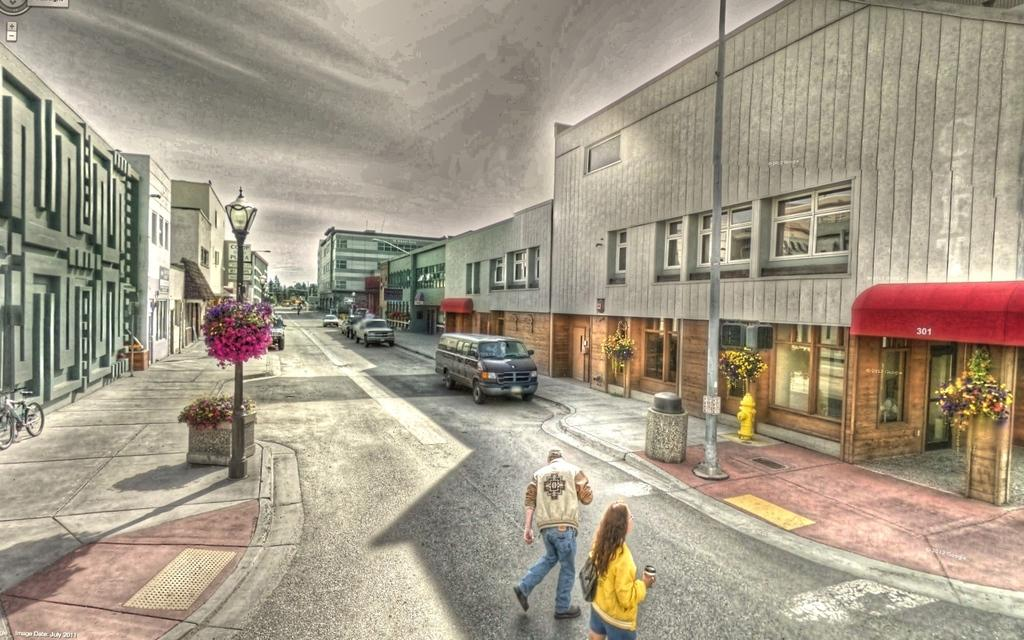What type of image is being described? The image is animated. What structures can be seen in the image? There are buildings in the image. What vehicles are present in the image? Cars are parked on the road in the image. What other objects can be seen in the image? There are electrical poles in the image. What are the people in the image doing? People are walking on the road in the image. What type of gift did the daughter receive for her birthday in the image? There is no daughter or birthday present in the image; it is an animated scene with buildings, cars, electrical poles, and people walking on the road. 